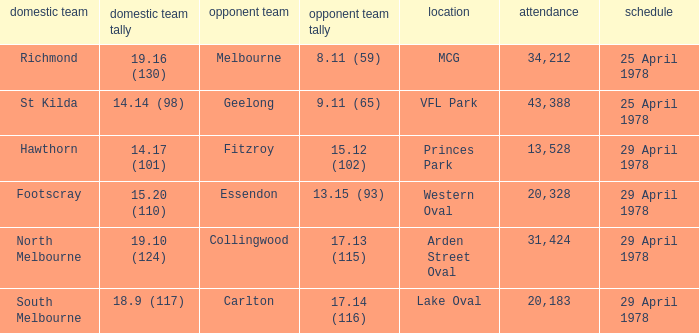Who was the home team at MCG? Richmond. 